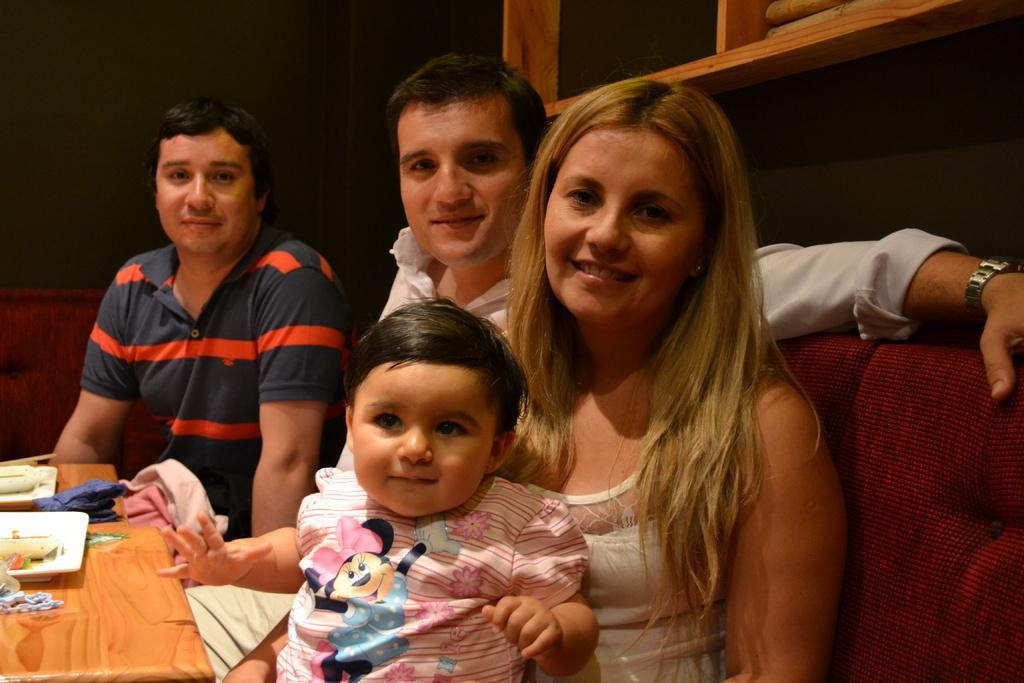Please provide a concise description of this image. In this picture I can see three persons sitting on the couches and there is a kid sitting on the woman. I can see plates and some other items on the table, and in the background there are some objects. 